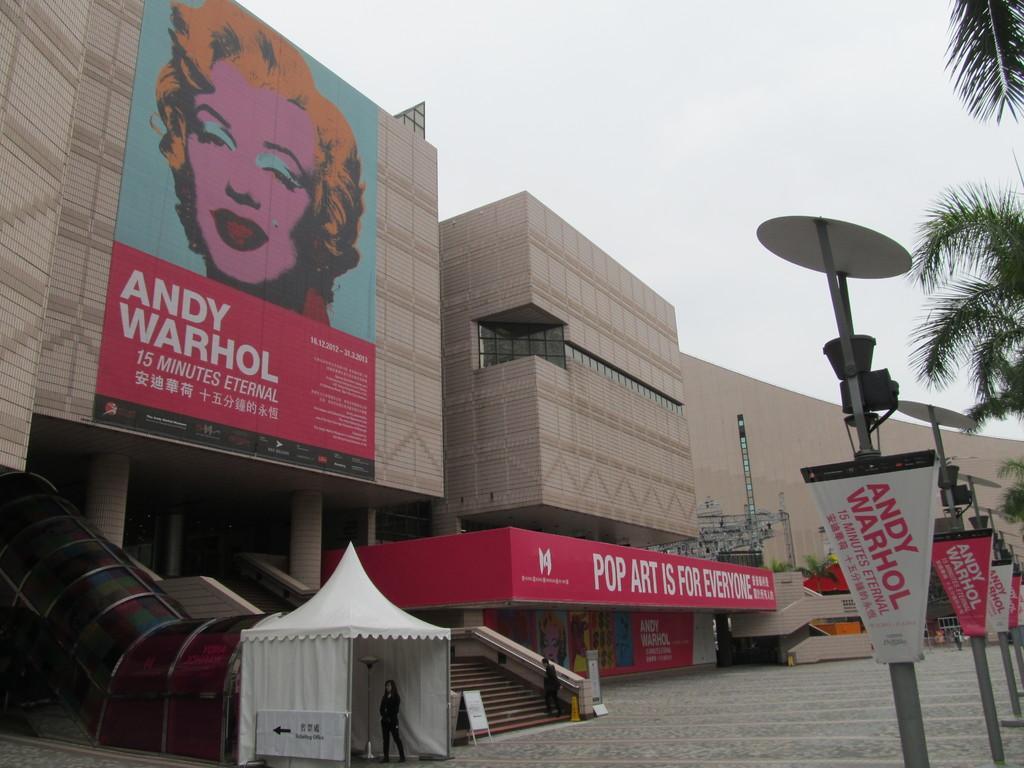Describe this image in one or two sentences. In this image, I can see a building with hoardings and a person standing on the stairs. At the bottom of the image, I can see another person standing in a tent. On the right side of the image, there are trees and street lights with boards. In the background, there is the sky. 